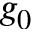<formula> <loc_0><loc_0><loc_500><loc_500>g _ { 0 }</formula> 